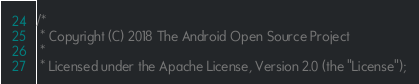Convert code to text. <code><loc_0><loc_0><loc_500><loc_500><_C_>/*
 * Copyright (C) 2018 The Android Open Source Project
 *
 * Licensed under the Apache License, Version 2.0 (the "License");</code> 